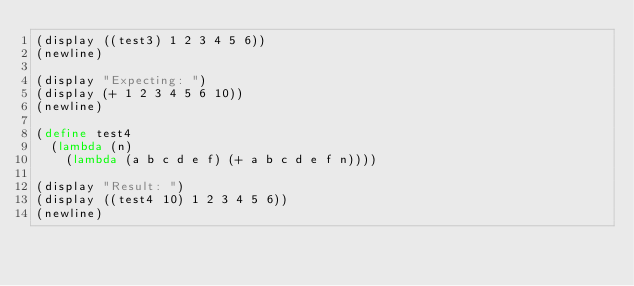<code> <loc_0><loc_0><loc_500><loc_500><_Scheme_>(display ((test3) 1 2 3 4 5 6))
(newline)

(display "Expecting: ")
(display (+ 1 2 3 4 5 6 10))
(newline)

(define test4
  (lambda (n)
    (lambda (a b c d e f) (+ a b c d e f n))))

(display "Result: ")
(display ((test4 10) 1 2 3 4 5 6))
(newline)
</code> 